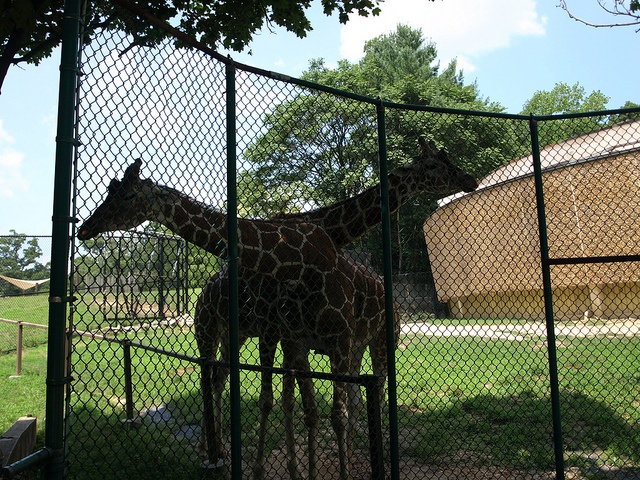Describe the objects in this image and their specific colors. I can see giraffe in black, gray, and darkgreen tones and giraffe in black, darkgreen, and gray tones in this image. 